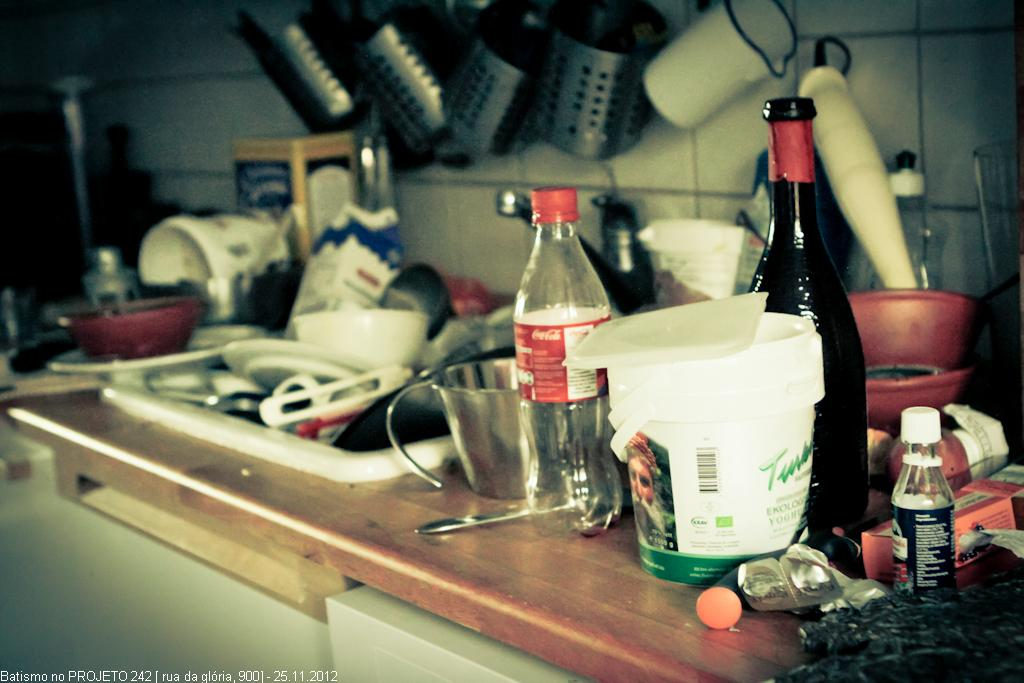What type of objects can be seen on the table in the image? There are bottles, utensils, and other objects on the table in the image. Can you describe the bottles on the table? Unfortunately, the facts provided do not give any specific details about the bottles. What other objects are present on the table besides bottles and utensils? The facts provided do not specify any other objects on the table. Is there a squirrel on the table in the image? No, there is no squirrel present in the image. What is the temper of the utensils on the table? Utensils do not have a temper; they are inanimate objects. 